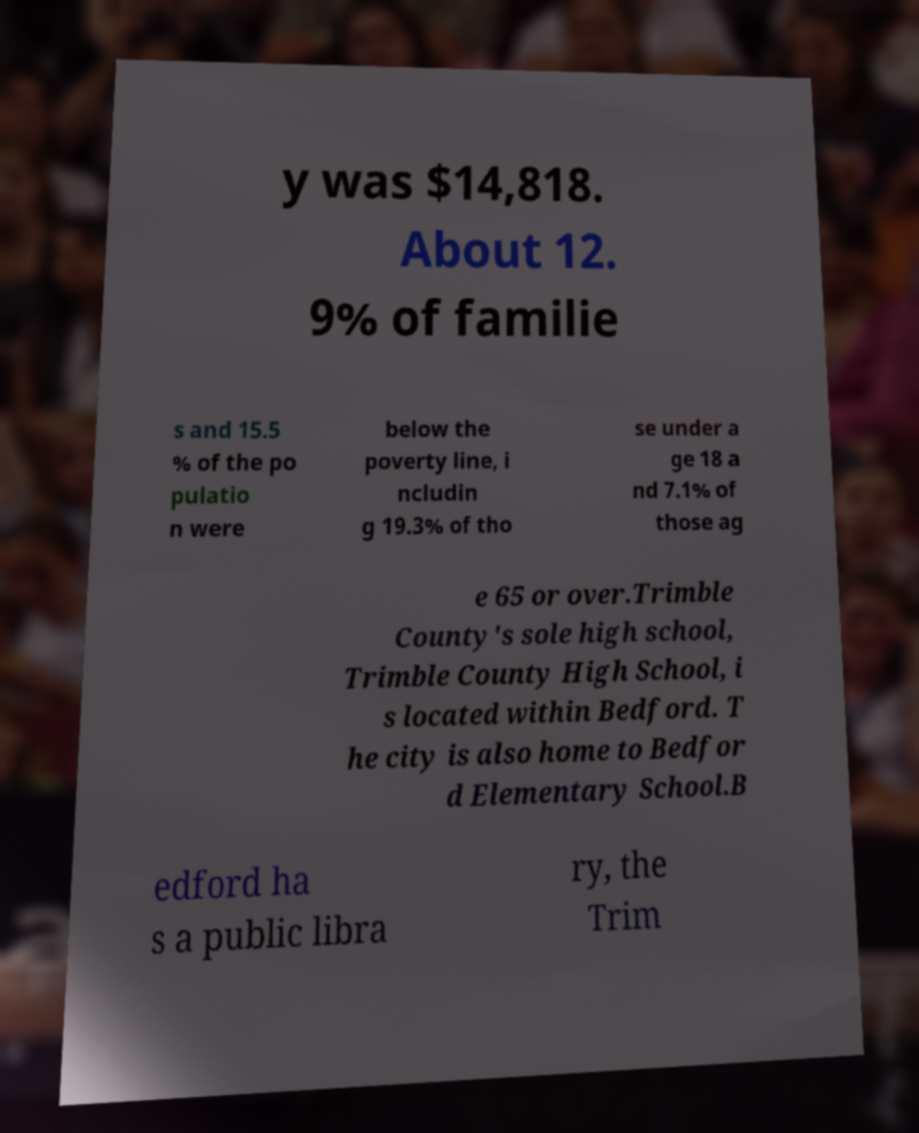Could you extract and type out the text from this image? y was $14,818. About 12. 9% of familie s and 15.5 % of the po pulatio n were below the poverty line, i ncludin g 19.3% of tho se under a ge 18 a nd 7.1% of those ag e 65 or over.Trimble County's sole high school, Trimble County High School, i s located within Bedford. T he city is also home to Bedfor d Elementary School.B edford ha s a public libra ry, the Trim 